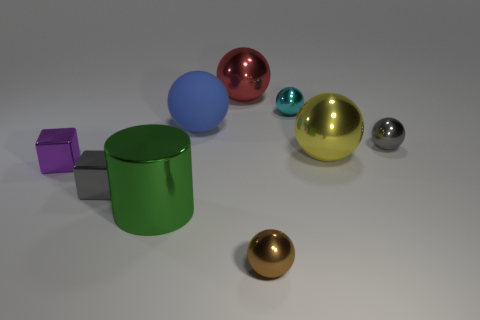There is a brown thing that is the same material as the tiny cyan thing; what size is it?
Make the answer very short. Small. Is the size of the gray shiny object behind the tiny purple metal block the same as the metallic ball that is to the left of the tiny brown shiny thing?
Give a very brief answer. No. What number of tiny things are red things or gray spheres?
Your answer should be very brief. 1. There is a sphere that is to the left of the big metallic sphere that is behind the small gray metal sphere; what is its material?
Keep it short and to the point. Rubber. Is there a small green block that has the same material as the purple block?
Ensure brevity in your answer.  No. Is the green object made of the same material as the blue sphere behind the gray shiny cube?
Ensure brevity in your answer.  No. There is a rubber thing that is the same size as the metal cylinder; what is its color?
Your response must be concise. Blue. What size is the gray metal thing that is in front of the small sphere that is on the right side of the cyan metal object?
Provide a short and direct response. Small. Are there fewer gray cubes behind the brown sphere than large things?
Ensure brevity in your answer.  Yes. What number of other things are there of the same size as the purple cube?
Your answer should be very brief. 4. 